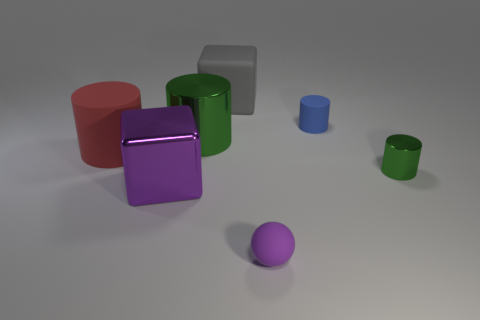There is a shiny thing that is the same color as the sphere; what size is it?
Keep it short and to the point. Large. What shape is the small thing that is both in front of the large matte cylinder and to the right of the tiny purple matte thing?
Your answer should be compact. Cylinder. What is the size of the cylinder that is on the left side of the gray rubber thing and to the right of the large red thing?
Offer a very short reply. Large. There is a rubber cylinder that is in front of the tiny matte thing behind the green cylinder to the right of the large gray matte thing; what is its size?
Provide a succinct answer. Large. What is the size of the blue thing?
Offer a terse response. Small. Is there any other thing that is the same material as the gray cube?
Ensure brevity in your answer.  Yes. There is a metallic cylinder that is in front of the matte cylinder that is to the left of the gray matte object; are there any things that are on the right side of it?
Make the answer very short. No. How many small things are either rubber cubes or red cylinders?
Offer a very short reply. 0. Are there any other things that are the same color as the rubber cube?
Your answer should be very brief. No. There is a rubber cylinder left of the matte cube; is it the same size as the large gray rubber object?
Offer a very short reply. Yes. 